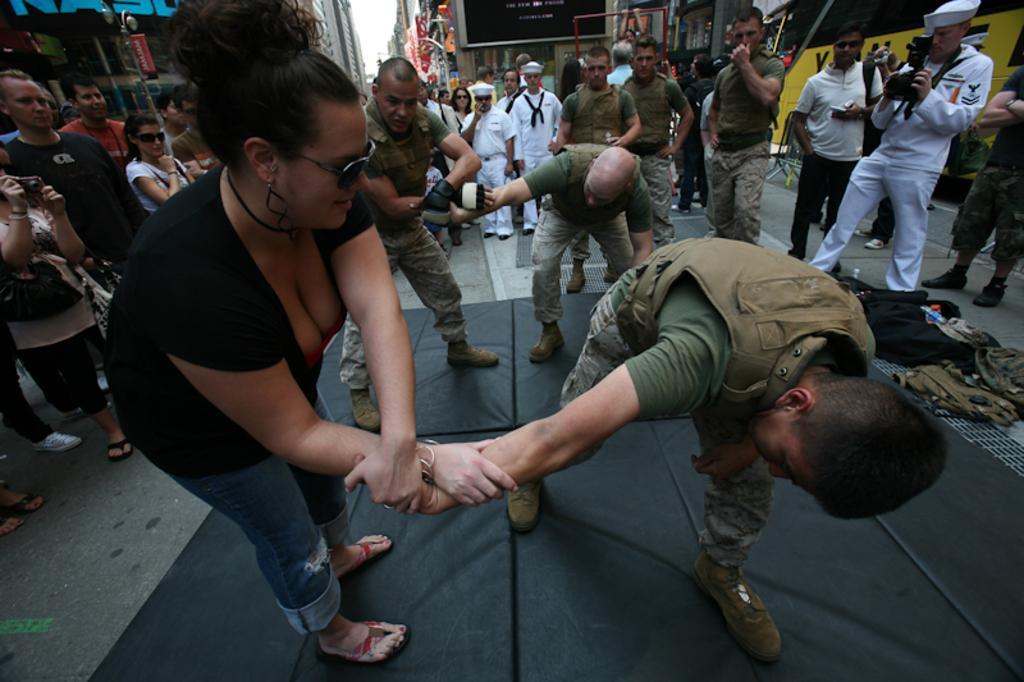Can you describe this image briefly? In this image we can see people practicing self defence. In the background there is crowd. The man standing on the right is holding a camera. At the bottom there are bags and mats. There are stores. 